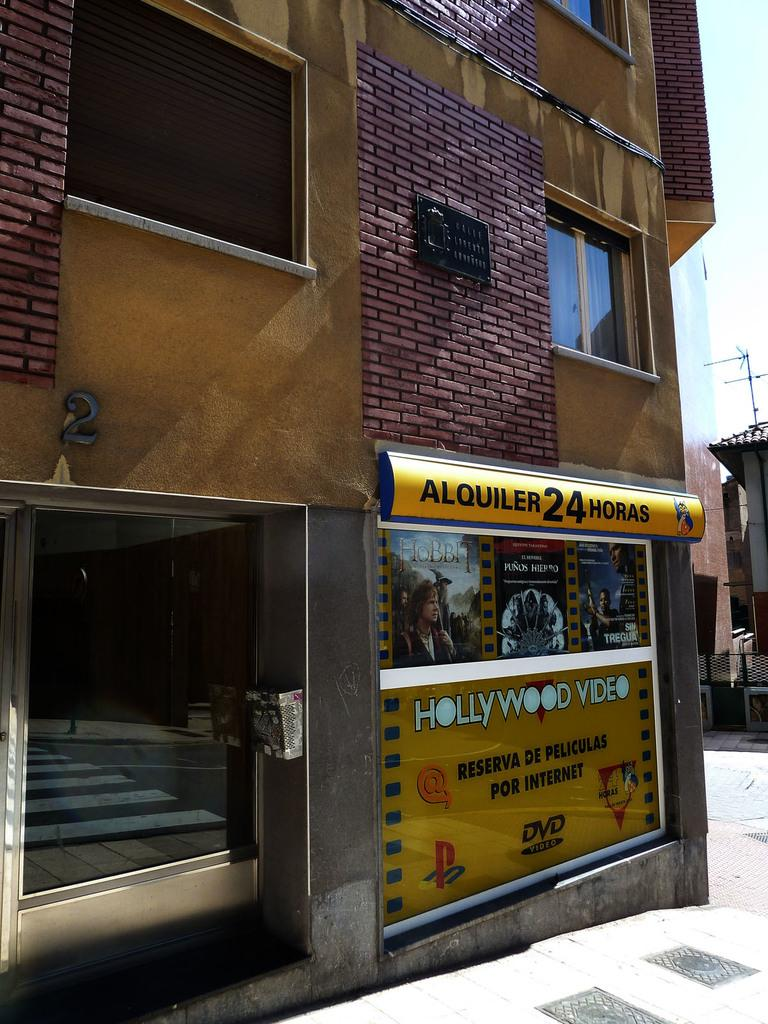<image>
Offer a succinct explanation of the picture presented. Hollywood Video according to a banner is open 24 hours. 